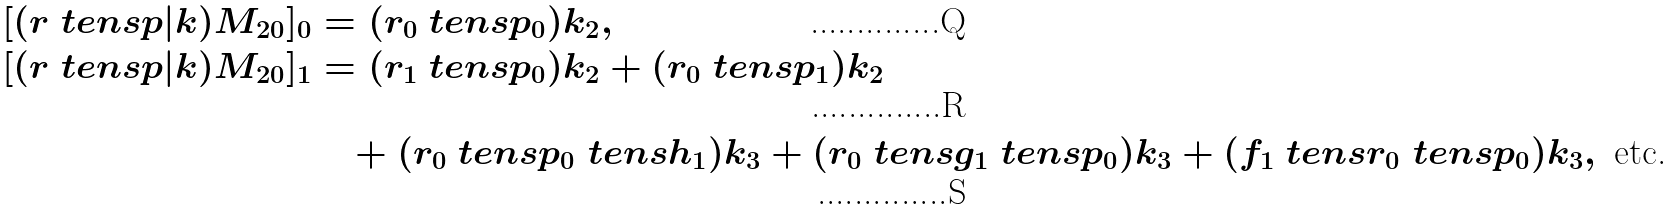<formula> <loc_0><loc_0><loc_500><loc_500>[ ( r \ t e n s p | k ) M _ { 2 0 } ] _ { 0 } & = ( r _ { 0 } \ t e n s p _ { 0 } ) k _ { 2 } , \\ [ ( r \ t e n s p | k ) M _ { 2 0 } ] _ { 1 } & = ( r _ { 1 } \ t e n s p _ { 0 } ) k _ { 2 } + ( r _ { 0 } \ t e n s p _ { 1 } ) k _ { 2 } \\ & \quad + ( r _ { 0 } \ t e n s p _ { 0 } \ t e n s h _ { 1 } ) k _ { 3 } + ( r _ { 0 } \ t e n s g _ { 1 } \ t e n s p _ { 0 } ) k _ { 3 } + ( f _ { 1 } \ t e n s r _ { 0 } \ t e n s p _ { 0 } ) k _ { 3 } , \text { etc.}</formula> 